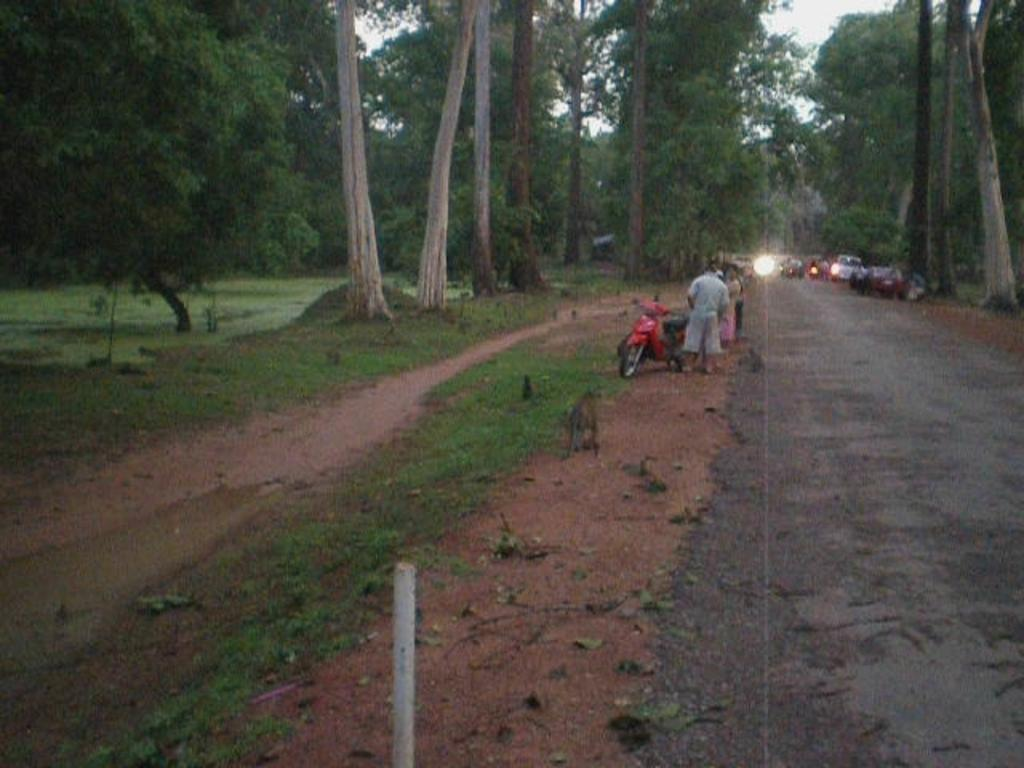What can be seen on the road in the image? There are vehicles on the road in the image. Who or what else is visible in the image? There are people visible in the image. What type of vegetation is present on both sides of the image? There are trees on the left side and the right side of the image. Can you tell me how many monkeys are sitting on the vehicles in the image? There are no monkeys present in the image; it features vehicles on the road and people nearby. What type of team is visible in the image? There is no team visible in the image; it features vehicles, people, and trees. 